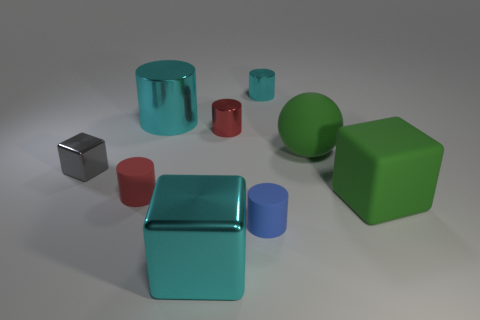The other cylinder that is the same color as the large shiny cylinder is what size?
Offer a terse response. Small. There is a small object that is the same color as the large metal cube; what shape is it?
Offer a terse response. Cylinder. Are there more large cyan blocks that are in front of the tiny red metal thing than brown blocks?
Offer a terse response. Yes. Are there any tiny blue cylinders made of the same material as the cyan cube?
Offer a terse response. No. There is a rubber object to the left of the big cyan block; does it have the same shape as the gray metallic thing?
Make the answer very short. No. How many small red rubber cylinders are behind the large shiny thing behind the matte object that is behind the gray metal block?
Provide a succinct answer. 0. Is the number of blue rubber cylinders that are on the left side of the small gray block less than the number of large green matte balls behind the tiny blue matte object?
Offer a very short reply. Yes. The other big metallic thing that is the same shape as the gray metal object is what color?
Provide a short and direct response. Cyan. What is the size of the green ball?
Your response must be concise. Large. How many cyan shiny cylinders are the same size as the red matte cylinder?
Provide a short and direct response. 1. 